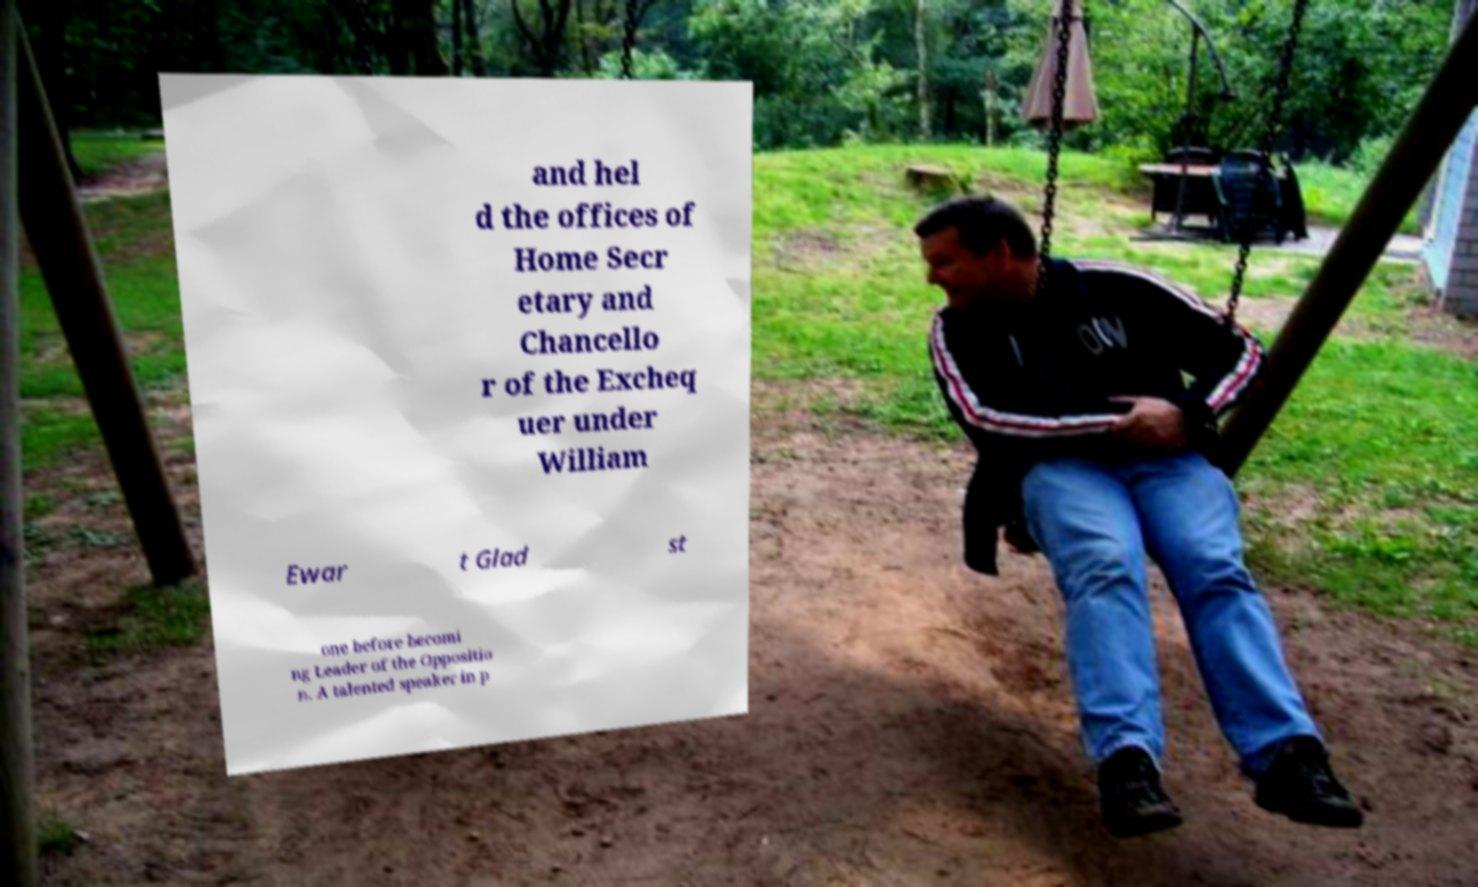Can you read and provide the text displayed in the image?This photo seems to have some interesting text. Can you extract and type it out for me? and hel d the offices of Home Secr etary and Chancello r of the Excheq uer under William Ewar t Glad st one before becomi ng Leader of the Oppositio n. A talented speaker in p 